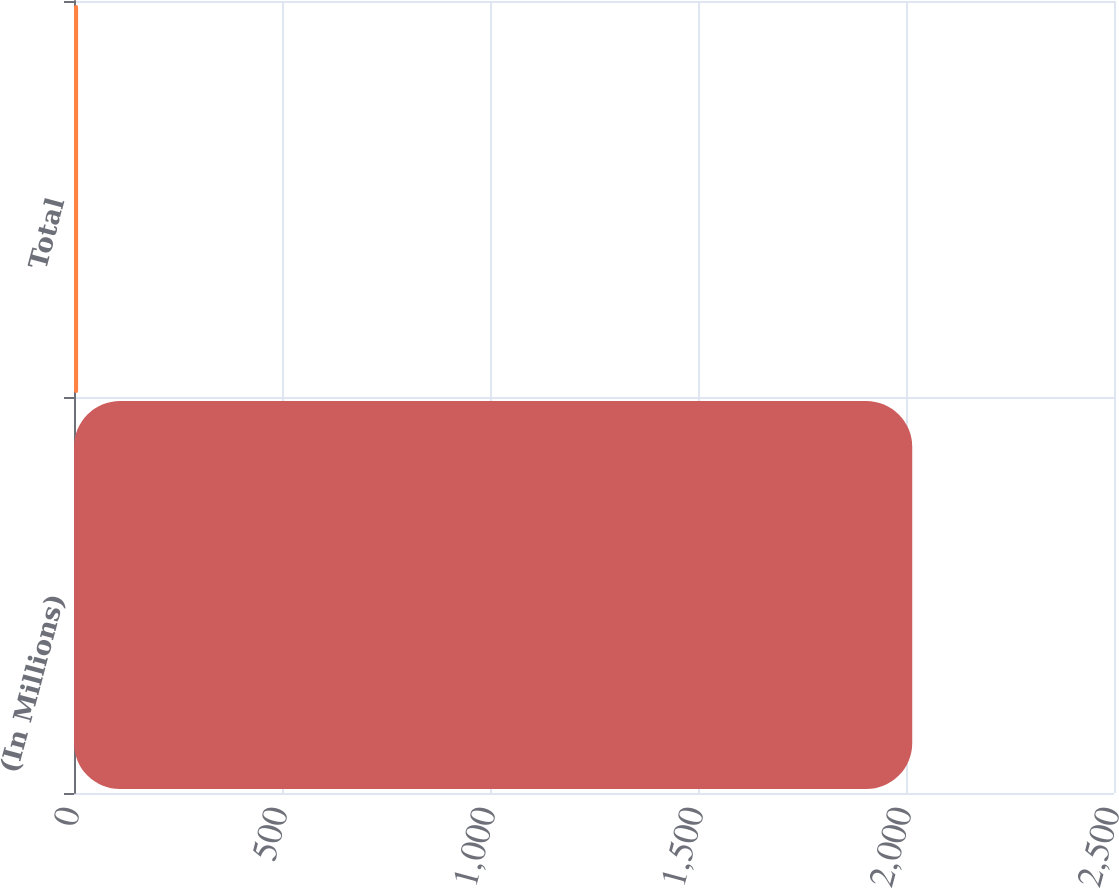<chart> <loc_0><loc_0><loc_500><loc_500><bar_chart><fcel>(In Millions)<fcel>Total<nl><fcel>2015<fcel>9.9<nl></chart> 